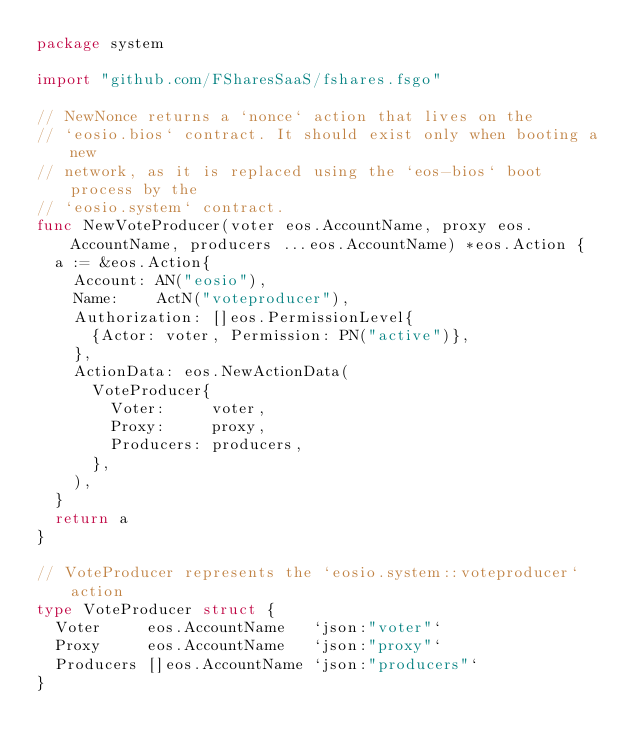Convert code to text. <code><loc_0><loc_0><loc_500><loc_500><_Go_>package system

import "github.com/FSharesSaaS/fshares.fsgo"

// NewNonce returns a `nonce` action that lives on the
// `eosio.bios` contract. It should exist only when booting a new
// network, as it is replaced using the `eos-bios` boot process by the
// `eosio.system` contract.
func NewVoteProducer(voter eos.AccountName, proxy eos.AccountName, producers ...eos.AccountName) *eos.Action {
	a := &eos.Action{
		Account: AN("eosio"),
		Name:    ActN("voteproducer"),
		Authorization: []eos.PermissionLevel{
			{Actor: voter, Permission: PN("active")},
		},
		ActionData: eos.NewActionData(
			VoteProducer{
				Voter:     voter,
				Proxy:     proxy,
				Producers: producers,
			},
		),
	}
	return a
}

// VoteProducer represents the `eosio.system::voteproducer` action
type VoteProducer struct {
	Voter     eos.AccountName   `json:"voter"`
	Proxy     eos.AccountName   `json:"proxy"`
	Producers []eos.AccountName `json:"producers"`
}
</code> 